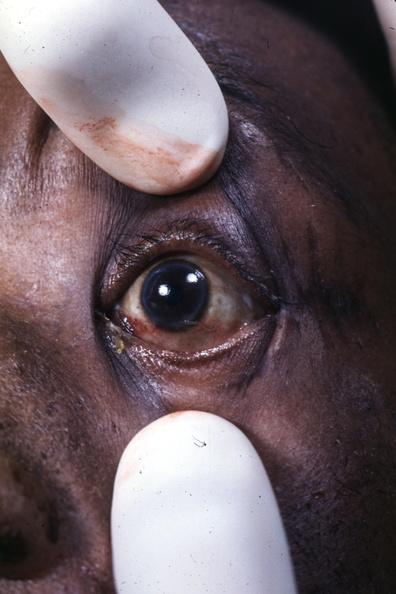s adenoma present?
Answer the question using a single word or phrase. No 